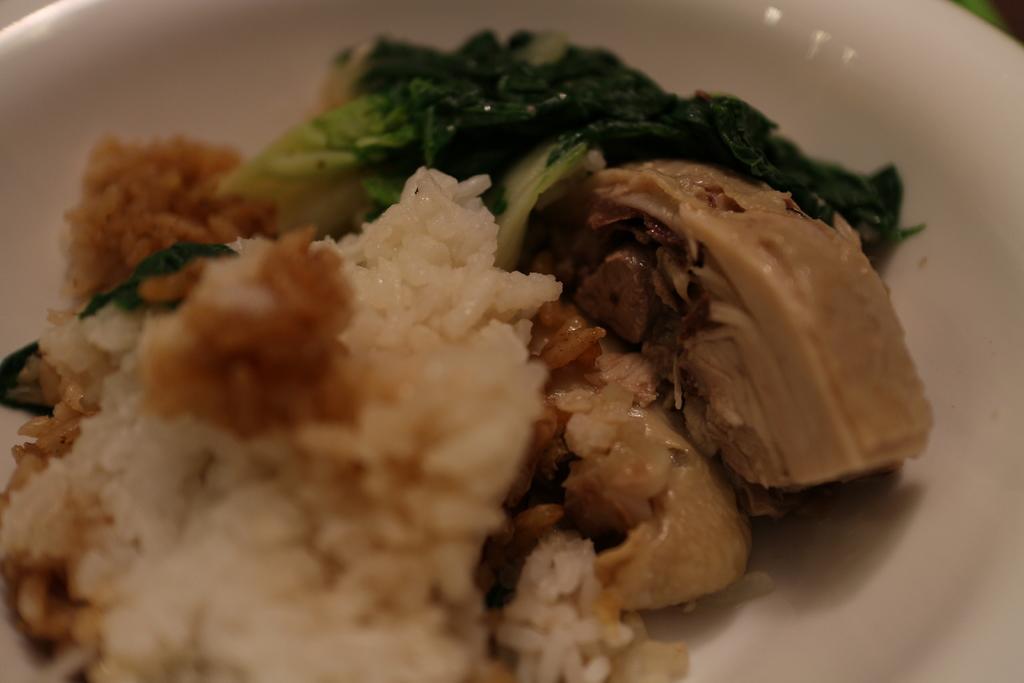In one or two sentences, can you explain what this image depicts? Here in this picture we can see rice, meat and other leafy vegetables present on a plate over there. 